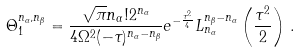<formula> <loc_0><loc_0><loc_500><loc_500>\Theta _ { 1 } ^ { n _ { \alpha } , n _ { \beta } } = \frac { \sqrt { \pi } n _ { \alpha } ! 2 ^ { n _ { \alpha } } } { 4 \Omega ^ { 2 } ( - \tau ) ^ { n _ { \alpha } - n _ { \beta } } } e ^ { - \frac { \tau ^ { 2 } } { 4 } } L _ { n _ { \alpha } } ^ { n _ { \beta } - n _ { \alpha } } \left ( \frac { \tau ^ { 2 } } { 2 } \right ) \, .</formula> 